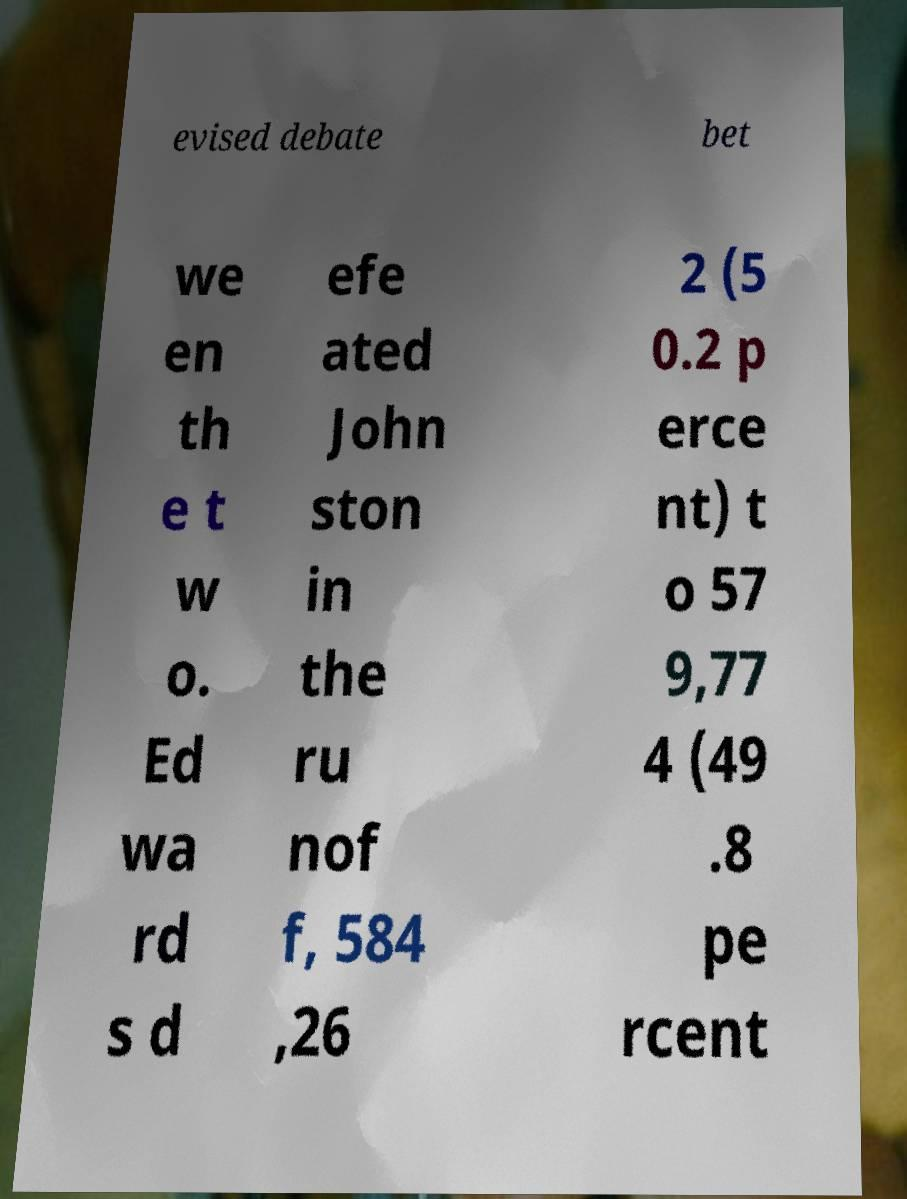Can you accurately transcribe the text from the provided image for me? evised debate bet we en th e t w o. Ed wa rd s d efe ated John ston in the ru nof f, 584 ,26 2 (5 0.2 p erce nt) t o 57 9,77 4 (49 .8 pe rcent 